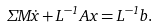Convert formula to latex. <formula><loc_0><loc_0><loc_500><loc_500>\Sigma M \dot { x } + L ^ { - 1 } A x = L ^ { - 1 } b .</formula> 